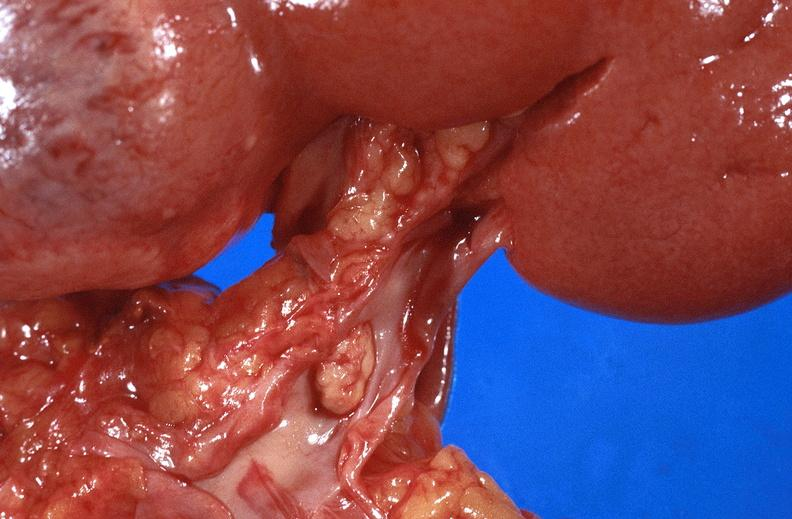what does this image show?
Answer the question using a single word or phrase. Renal cell carcinoma with extension into vena cava 